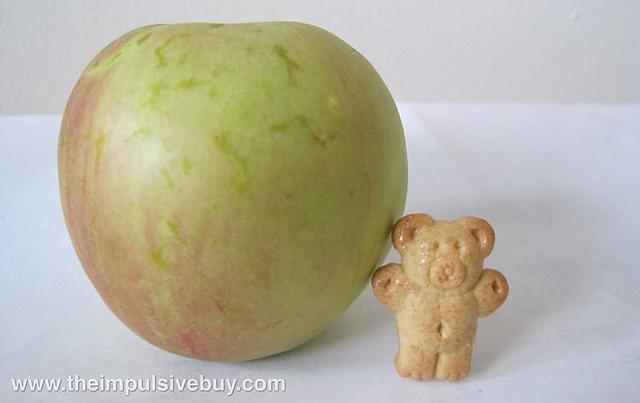Has someone bit into the apple?
Answer briefly. No. How many fruits are present?
Keep it brief. 1. Has this apple been partially eaten?
Write a very short answer. No. How many apples are there?
Quick response, please. 1. 